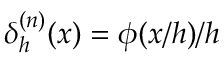Convert formula to latex. <formula><loc_0><loc_0><loc_500><loc_500>\delta _ { h } ^ { ( n ) } ( x ) = \phi ( x / h ) / h</formula> 